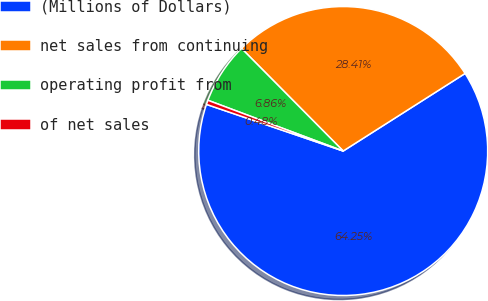Convert chart. <chart><loc_0><loc_0><loc_500><loc_500><pie_chart><fcel>(Millions of Dollars)<fcel>net sales from continuing<fcel>operating profit from<fcel>of net sales<nl><fcel>64.25%<fcel>28.41%<fcel>6.86%<fcel>0.48%<nl></chart> 